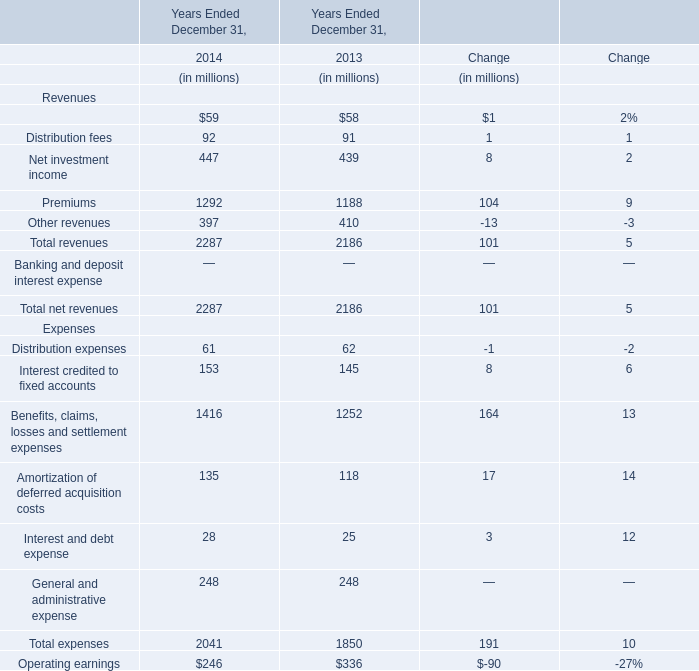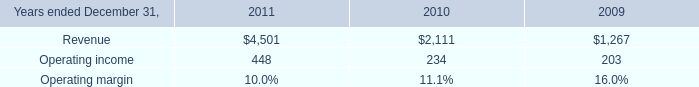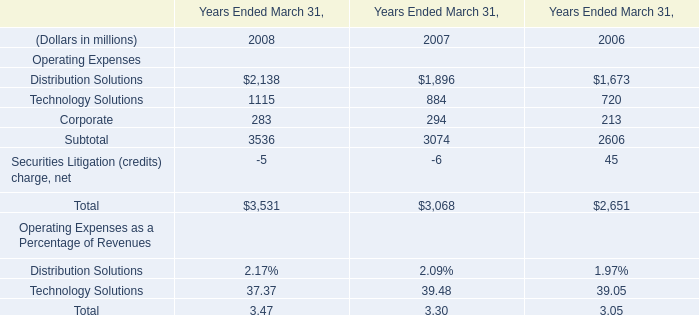What will total revenues reach in 2015 if it continues to grow at its current rate? (in million) 
Computations: ((((2287 - 2186) / 2186) + 1) * 2287)
Answer: 2392.66651. 